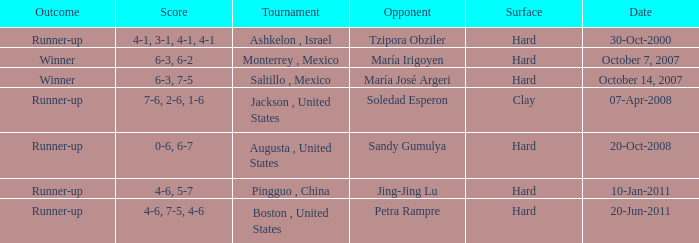Which tournament was held on October 14, 2007? Saltillo , Mexico. 